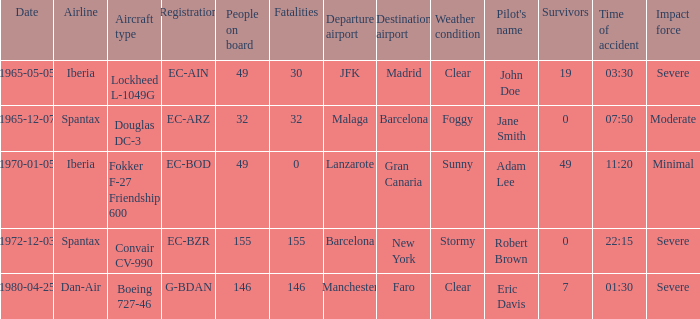How many fatalities are there for the airline of spantax, with a registration of ec-arz? 32.0. 